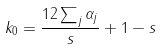Convert formula to latex. <formula><loc_0><loc_0><loc_500><loc_500>k _ { 0 } = \frac { 1 2 \sum _ { j } \alpha _ { j } } { s } + 1 - s</formula> 